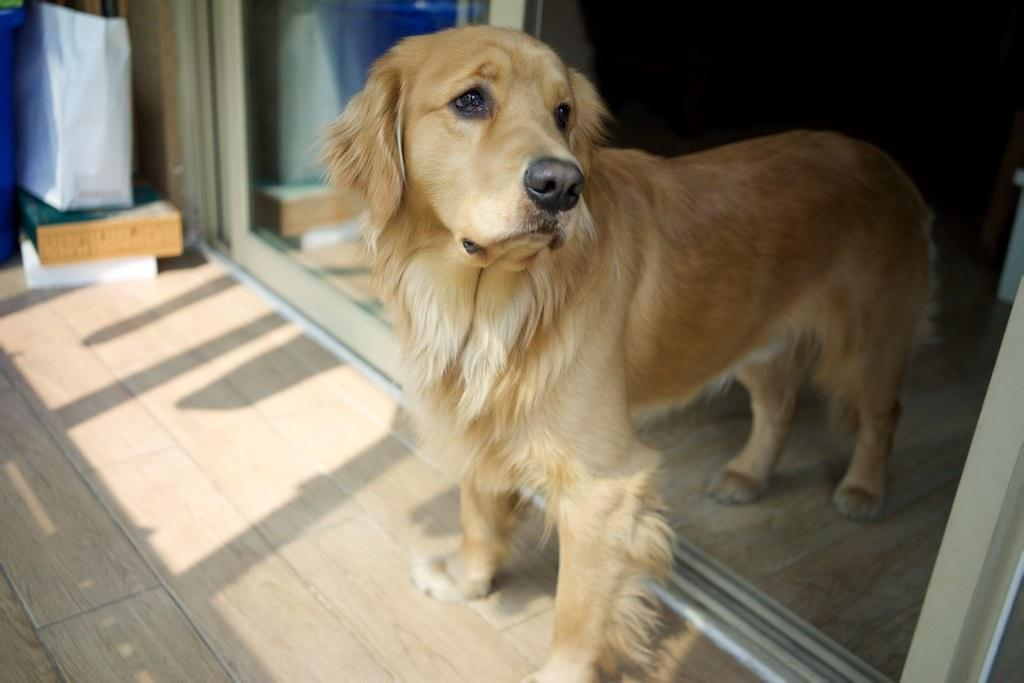What is the main subject of the image? There is a dog in the middle of the image. Can you describe the dog's appearance? The dog is in cream color. What can be seen in the background of the image? The background of the image is dark. What type of creature is joining the dog in the image? There is no other creature present in the image besides the dog. What kind of soda is the dog holding in the image? The dog is not holding any soda in the image; it is simply a dog in the middle of the image. 